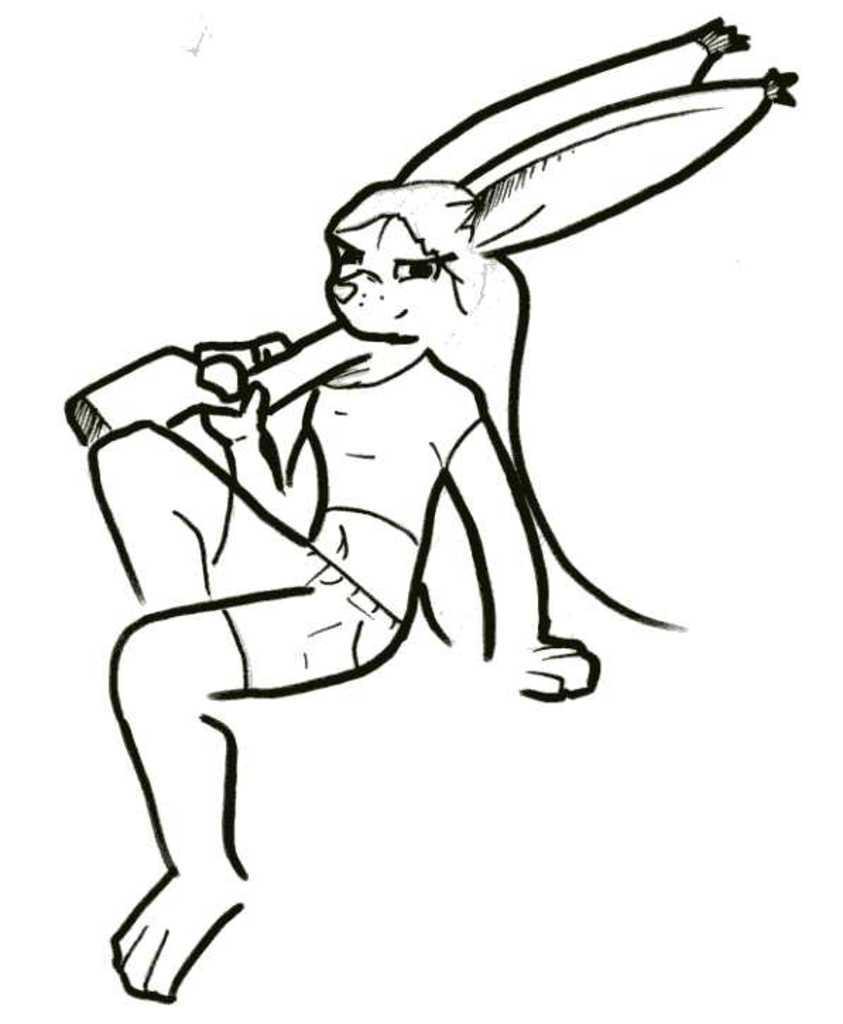Please provide a concise description of this image. In this image, I can see the drawing of a cartoon character. There is a white background. 